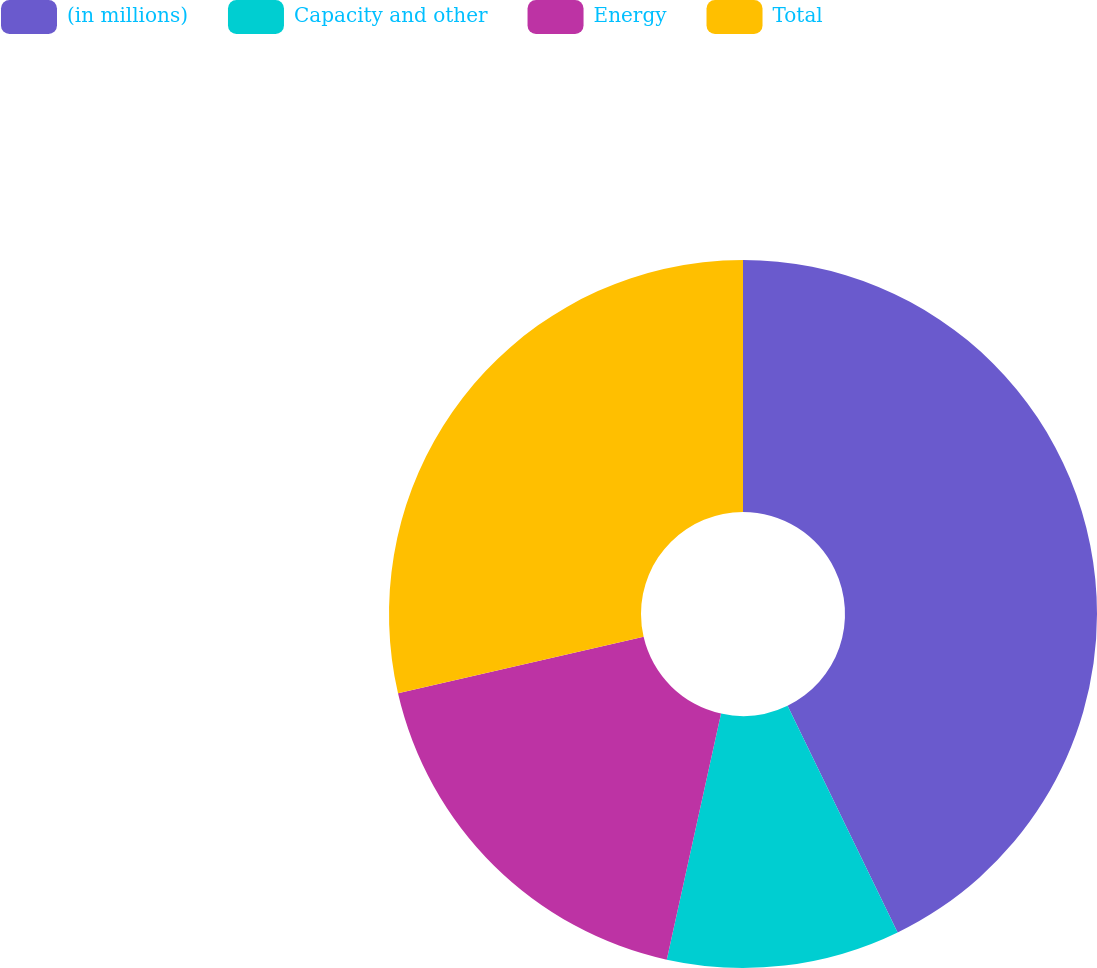<chart> <loc_0><loc_0><loc_500><loc_500><pie_chart><fcel>(in millions)<fcel>Capacity and other<fcel>Energy<fcel>Total<nl><fcel>42.81%<fcel>10.65%<fcel>17.95%<fcel>28.6%<nl></chart> 